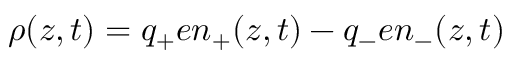Convert formula to latex. <formula><loc_0><loc_0><loc_500><loc_500>\rho ( z , t ) = q _ { + } e n _ { + } ( z , t ) - q _ { - } e n _ { - } ( z , t )</formula> 